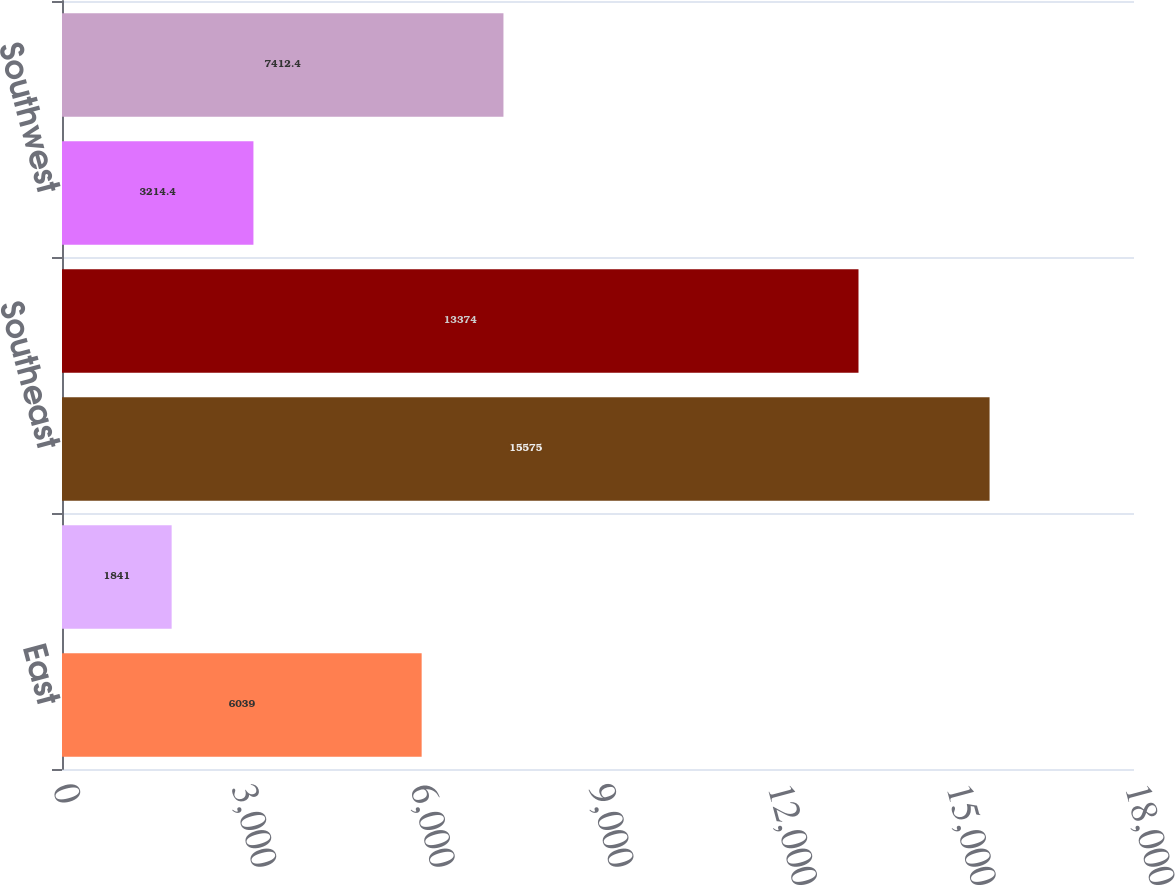<chart> <loc_0><loc_0><loc_500><loc_500><bar_chart><fcel>East<fcel>Midwest<fcel>Southeast<fcel>South Central<fcel>Southwest<fcel>West<nl><fcel>6039<fcel>1841<fcel>15575<fcel>13374<fcel>3214.4<fcel>7412.4<nl></chart> 